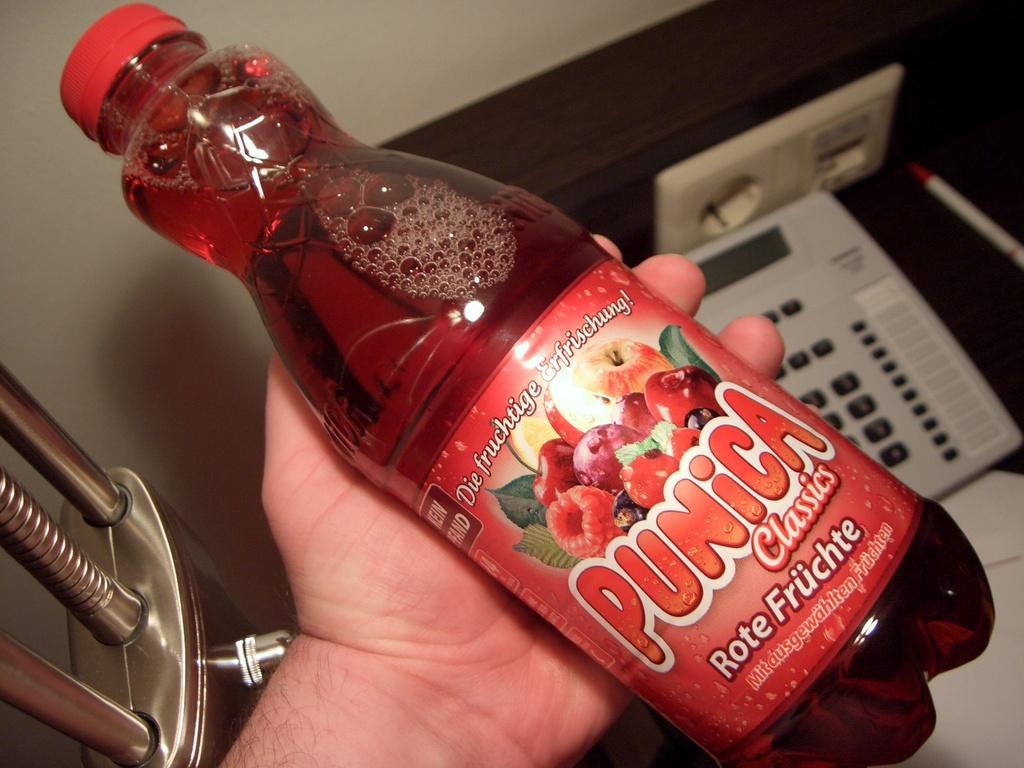Can you describe this image briefly? In this image, there is a hand holding a bottle. This bottle has a label and contains some text. There is a telephone on the right side of the image. 